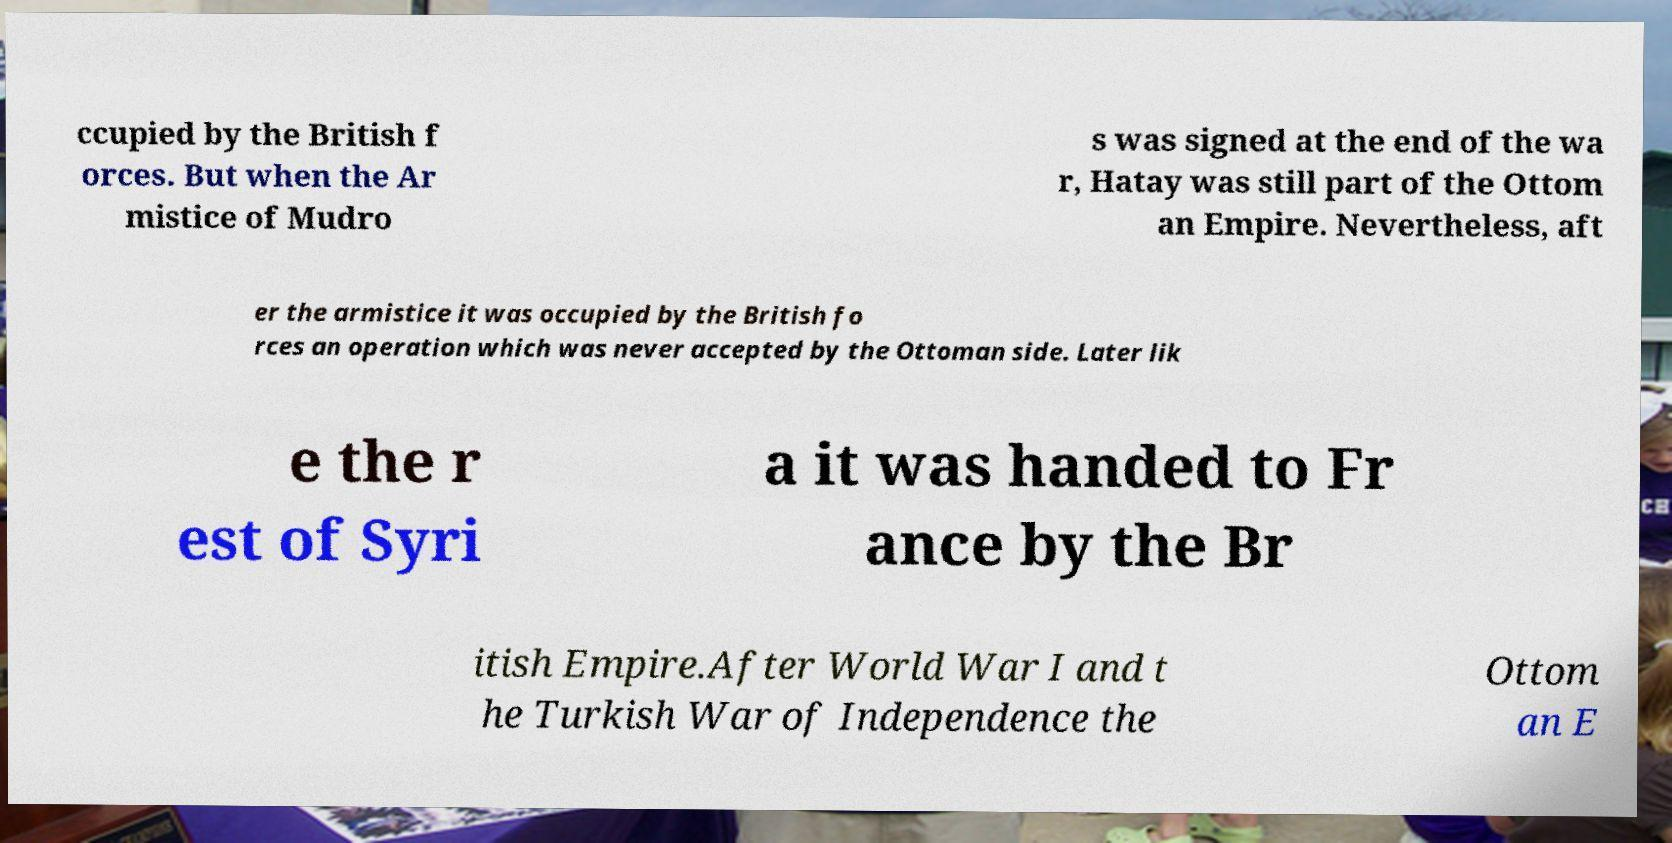Could you extract and type out the text from this image? ccupied by the British f orces. But when the Ar mistice of Mudro s was signed at the end of the wa r, Hatay was still part of the Ottom an Empire. Nevertheless, aft er the armistice it was occupied by the British fo rces an operation which was never accepted by the Ottoman side. Later lik e the r est of Syri a it was handed to Fr ance by the Br itish Empire.After World War I and t he Turkish War of Independence the Ottom an E 